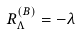Convert formula to latex. <formula><loc_0><loc_0><loc_500><loc_500>R ^ { ( B ) } _ { \Lambda } = - \lambda</formula> 